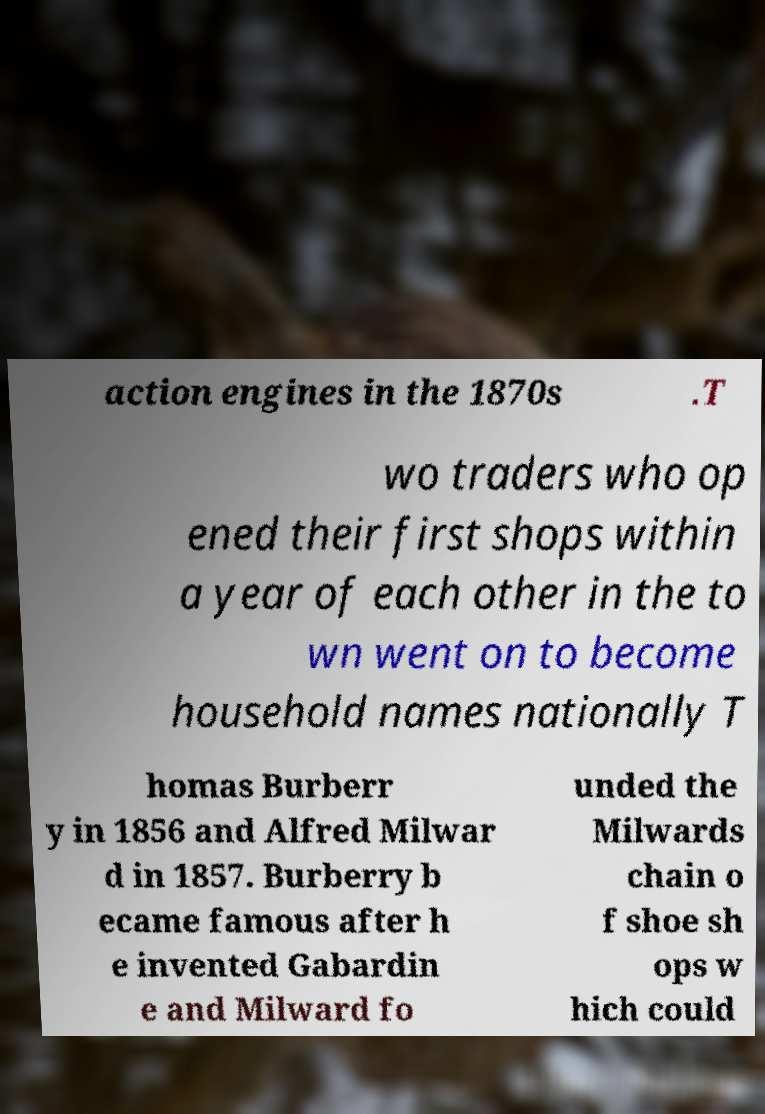What messages or text are displayed in this image? I need them in a readable, typed format. action engines in the 1870s .T wo traders who op ened their first shops within a year of each other in the to wn went on to become household names nationally T homas Burberr y in 1856 and Alfred Milwar d in 1857. Burberry b ecame famous after h e invented Gabardin e and Milward fo unded the Milwards chain o f shoe sh ops w hich could 